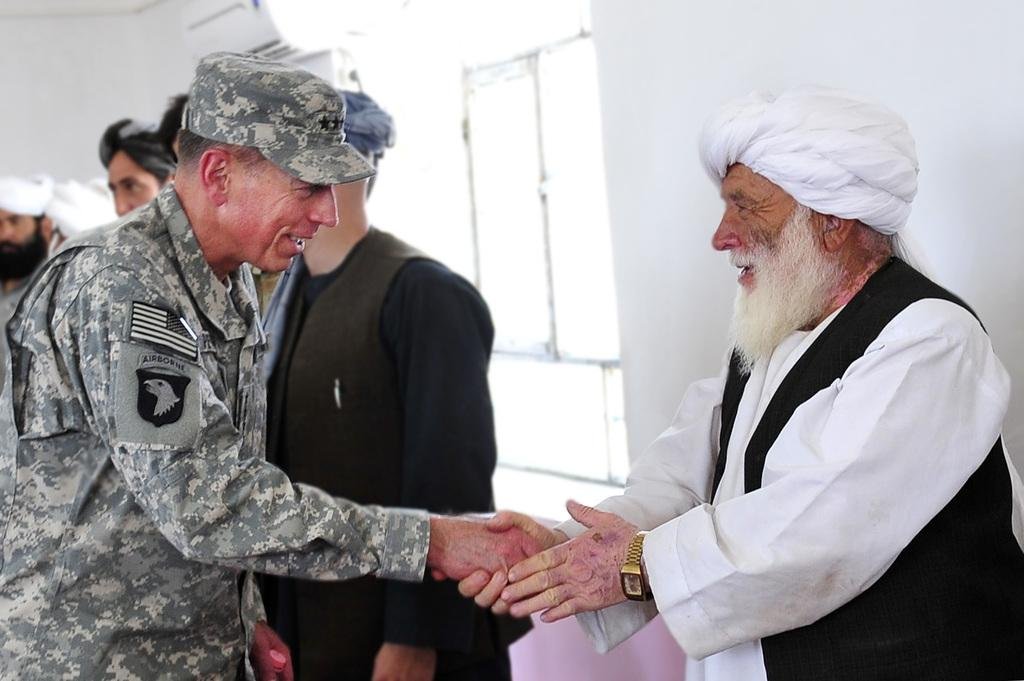How many people are in the image? There are two persons in the image. What are the two persons doing in the image? The two persons are shaking hands. Can you describe the clothing worn by the persons in the image? The two persons are wearing clothes. Where is the person standing in the image? There is a person standing in front of a wall in the image. What date is marked on the calendar in the image? There is no calendar present in the image. How does the person's nose appear in the image? There is no specific mention of a person's nose in the image, so it cannot be described. 